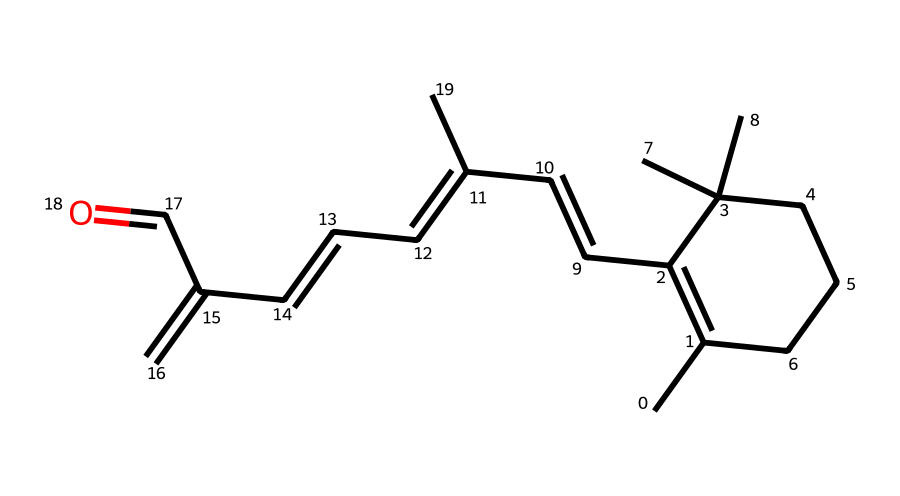What is the main functional group present in the structure? The chemical structure includes an aldehyde group indicated by the presence of a carbonyl (C=O) at the terminal carbon, which characterizes it as a functional group.
Answer: aldehyde How many double bonds are present in the chemical? By inspecting the structure, you can note that there are four double bonds between carbon atoms. Each double bond is indicated by the presence of a pair of carbon atoms connected by two lines instead of one.
Answer: four What does the presence of geometric isomers in this compound imply? The presence of double bonds within the molecule allows for different spatial arrangements of groups attached to the double-bonded carbon atoms. This leads to the possibility of geometric isomers, such as cis and trans forms.
Answer: spatial arrangements Which geometric isomer would be more prevalent in this structure? Consider the spatial arrangement around the double bonds: the presence of bulky groups on the same side of the double bond (cis) is typically more stable due to lower steric hindrance than oppositely placed groups (trans).
Answer: cis How many total carbon atoms are there in the structure? By carefully counting all the carbon atoms represented in the structure, we find that there are 20 carbon atoms present throughout the molecule.
Answer: 20 What physical state is likely for this compound at room temperature? Given that retinol is a vitamin and is generally found as an oily liquid or semi-solid, it is typically a viscous liquid at room temperature and therefore will likely exhibit an oily consistency.
Answer: liquid 